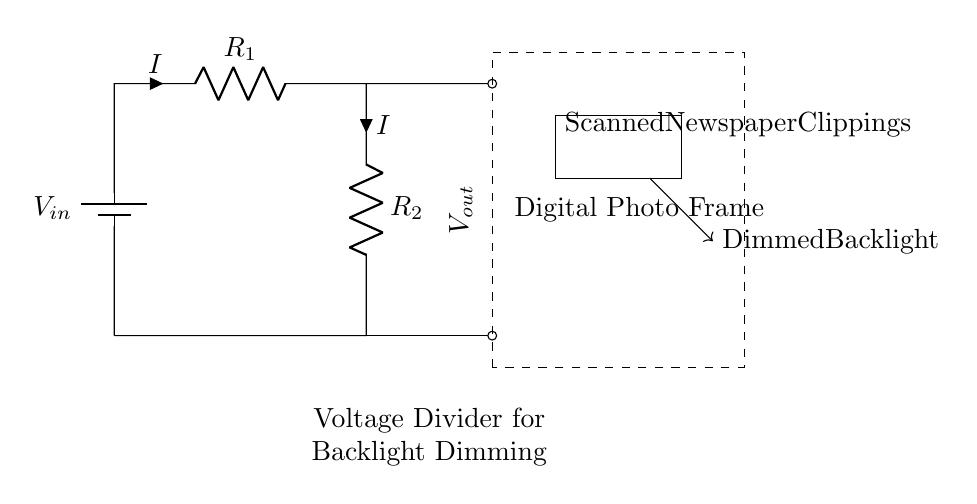What are the resistors in this circuit? The diagram shows two resistors labeled R1 and R2 connected in series. These resistors are part of the voltage divider circuit.
Answer: R1, R2 What is the function of the voltage divider in this circuit? The voltage divider reduces the input voltage to a level suitable for the digital photo frame's backlight, allowing it to be dimmed.
Answer: Dimming backlight What is the current flowing through the resistors? In a series circuit, the same current flows through all components. The current shown is labeled as I, implying that it is the same through both R1 and R2.
Answer: I What is the output voltage of the voltage divider? The output voltage Vout can be derived based on the voltage divider rule, which is the portion of input voltage seen across R2. It can be calculated as Vout = Vin * (R2 / (R1 + R2)).
Answer: Vout What happens when R1 is increased? Increasing R1 will decrease Vout since it alters the voltage division ratio, thus reducing the voltage available to the digital photo frame's backlight.
Answer: Vout decreases What is the significance of the dashed rectangle in the diagram? The dashed rectangle indicates the section of the circuit representing the digital photo frame, marking it off from the rest of the components in the circuit.
Answer: Digital photo frame 